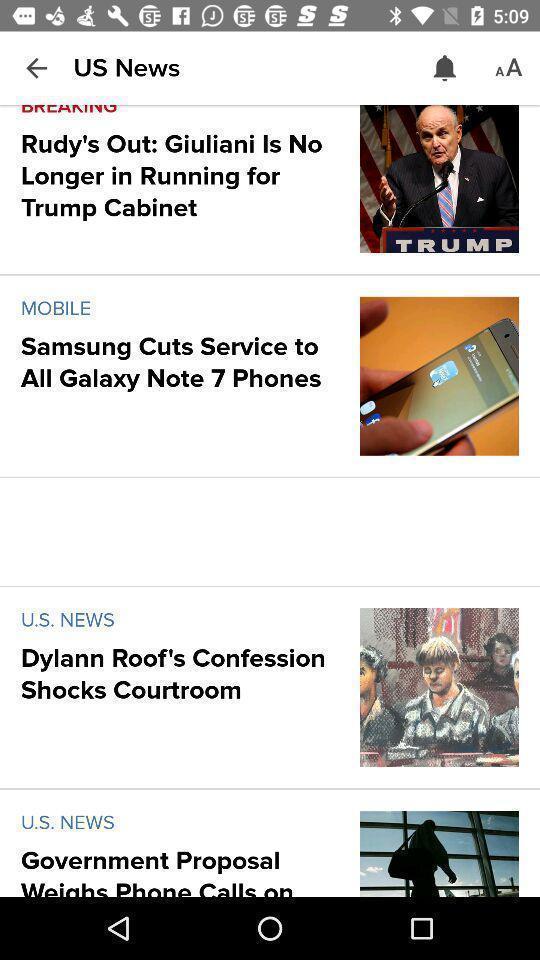Tell me what you see in this picture. Page showing about different news feed. 